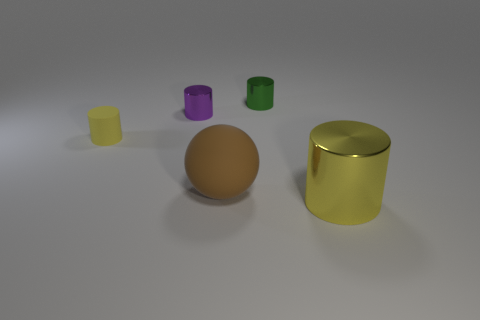What is the size of the yellow cylinder that is behind the yellow cylinder that is right of the tiny yellow rubber cylinder?
Give a very brief answer. Small. There is a tiny metal thing in front of the green shiny object; is it the same color as the metallic object that is to the right of the small green metal thing?
Ensure brevity in your answer.  No. The metal cylinder that is in front of the small green shiny cylinder and to the right of the brown sphere is what color?
Ensure brevity in your answer.  Yellow. What number of other things are there of the same shape as the large brown rubber thing?
Your response must be concise. 0. The matte thing that is the same size as the purple shiny object is what color?
Provide a short and direct response. Yellow. What is the color of the big thing behind the yellow metal cylinder?
Give a very brief answer. Brown. Are there any yellow metal cylinders that are in front of the yellow cylinder right of the yellow rubber object?
Give a very brief answer. No. There is a yellow rubber object; is its shape the same as the large thing left of the large metal thing?
Offer a very short reply. No. There is a cylinder that is on the right side of the tiny yellow thing and in front of the purple thing; what size is it?
Your response must be concise. Large. Is there another small cylinder that has the same material as the tiny green cylinder?
Ensure brevity in your answer.  Yes. 